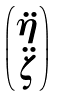<formula> <loc_0><loc_0><loc_500><loc_500>\begin{pmatrix} \ddot { \eta } \\ \ddot { \zeta } \end{pmatrix}</formula> 